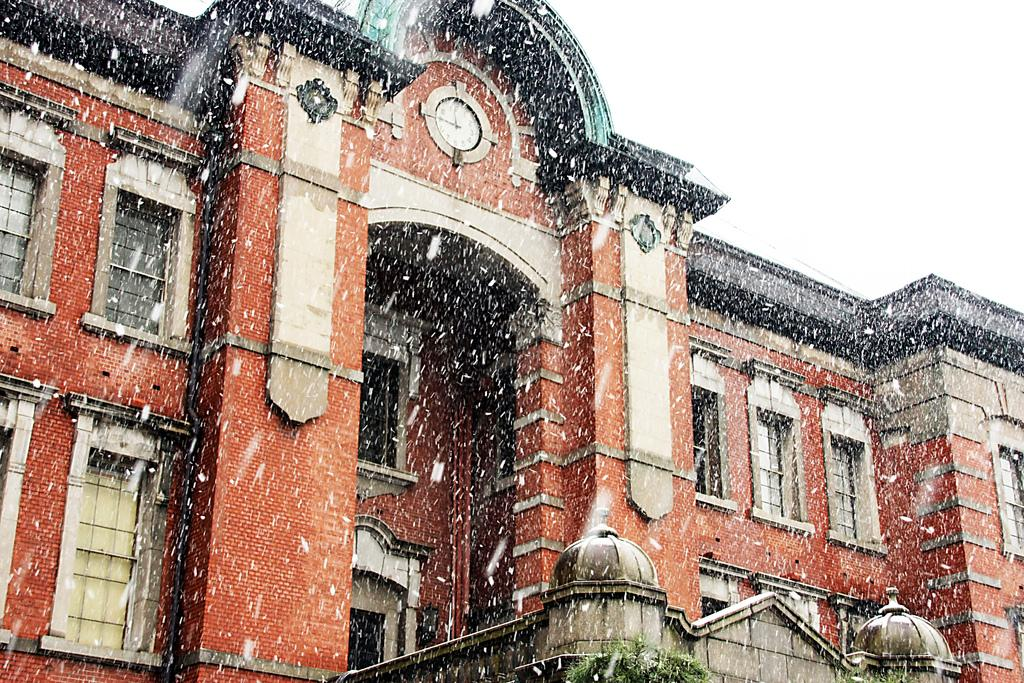What type of structure is in the image? There is a building in the image. What material is used for the walls of the building? The building has brick walls. What type of windows are on the building? The building has glass windows. What time-related object is in the image? There is a clock in the image. What type of vegetation is visible at the bottom of the image? Tree leaves are visible at the bottom of the image. What weather condition is occurring in the image? Snow is falling in the image. What advice does the clock give to the snow in the image? There is no interaction between the clock and the snow in the image, so no advice is given. 